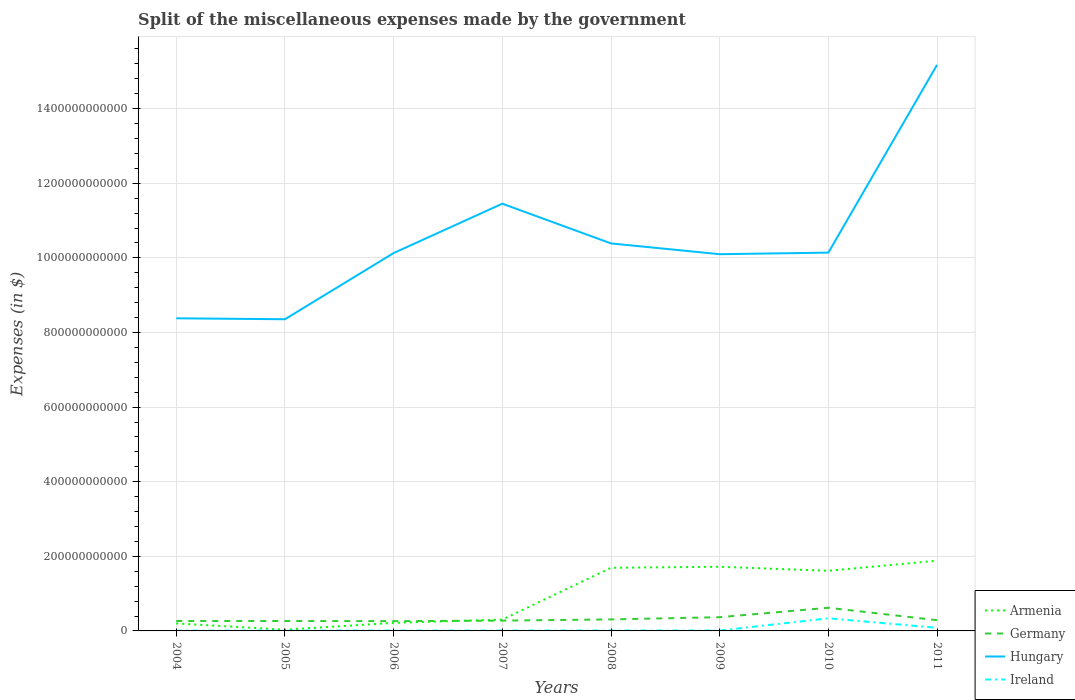How many different coloured lines are there?
Your answer should be compact. 4. Does the line corresponding to Ireland intersect with the line corresponding to Hungary?
Give a very brief answer. No. Across all years, what is the maximum miscellaneous expenses made by the government in Hungary?
Keep it short and to the point. 8.36e+11. What is the total miscellaneous expenses made by the government in Hungary in the graph?
Ensure brevity in your answer.  -5.08e+11. What is the difference between the highest and the second highest miscellaneous expenses made by the government in Armenia?
Provide a short and direct response. 1.85e+11. Is the miscellaneous expenses made by the government in Germany strictly greater than the miscellaneous expenses made by the government in Hungary over the years?
Your response must be concise. Yes. How many years are there in the graph?
Make the answer very short. 8. What is the difference between two consecutive major ticks on the Y-axis?
Offer a very short reply. 2.00e+11. Does the graph contain any zero values?
Make the answer very short. No. Where does the legend appear in the graph?
Your response must be concise. Bottom right. How are the legend labels stacked?
Provide a short and direct response. Vertical. What is the title of the graph?
Your response must be concise. Split of the miscellaneous expenses made by the government. Does "Middle East & North Africa (all income levels)" appear as one of the legend labels in the graph?
Offer a very short reply. No. What is the label or title of the X-axis?
Ensure brevity in your answer.  Years. What is the label or title of the Y-axis?
Offer a very short reply. Expenses (in $). What is the Expenses (in $) in Armenia in 2004?
Your response must be concise. 2.00e+1. What is the Expenses (in $) of Germany in 2004?
Offer a terse response. 2.66e+1. What is the Expenses (in $) of Hungary in 2004?
Keep it short and to the point. 8.38e+11. What is the Expenses (in $) in Ireland in 2004?
Give a very brief answer. 5.91e+08. What is the Expenses (in $) in Armenia in 2005?
Offer a terse response. 3.30e+09. What is the Expenses (in $) of Germany in 2005?
Provide a short and direct response. 2.66e+1. What is the Expenses (in $) of Hungary in 2005?
Provide a succinct answer. 8.36e+11. What is the Expenses (in $) in Ireland in 2005?
Make the answer very short. 7.97e+08. What is the Expenses (in $) of Armenia in 2006?
Provide a succinct answer. 2.16e+1. What is the Expenses (in $) in Germany in 2006?
Offer a terse response. 2.62e+1. What is the Expenses (in $) in Hungary in 2006?
Ensure brevity in your answer.  1.01e+12. What is the Expenses (in $) in Ireland in 2006?
Offer a very short reply. 9.16e+08. What is the Expenses (in $) of Armenia in 2007?
Ensure brevity in your answer.  3.04e+1. What is the Expenses (in $) of Germany in 2007?
Your answer should be compact. 2.76e+1. What is the Expenses (in $) of Hungary in 2007?
Your response must be concise. 1.15e+12. What is the Expenses (in $) in Ireland in 2007?
Keep it short and to the point. 9.75e+08. What is the Expenses (in $) of Armenia in 2008?
Provide a succinct answer. 1.69e+11. What is the Expenses (in $) in Germany in 2008?
Your answer should be compact. 3.09e+1. What is the Expenses (in $) of Hungary in 2008?
Provide a succinct answer. 1.04e+12. What is the Expenses (in $) in Ireland in 2008?
Offer a terse response. 1.01e+09. What is the Expenses (in $) of Armenia in 2009?
Offer a terse response. 1.72e+11. What is the Expenses (in $) in Germany in 2009?
Your answer should be very brief. 3.68e+1. What is the Expenses (in $) in Hungary in 2009?
Give a very brief answer. 1.01e+12. What is the Expenses (in $) in Ireland in 2009?
Offer a terse response. 9.94e+08. What is the Expenses (in $) in Armenia in 2010?
Offer a very short reply. 1.61e+11. What is the Expenses (in $) of Germany in 2010?
Provide a short and direct response. 6.21e+1. What is the Expenses (in $) of Hungary in 2010?
Ensure brevity in your answer.  1.01e+12. What is the Expenses (in $) in Ireland in 2010?
Provide a succinct answer. 3.38e+1. What is the Expenses (in $) of Armenia in 2011?
Keep it short and to the point. 1.88e+11. What is the Expenses (in $) in Germany in 2011?
Offer a terse response. 2.88e+1. What is the Expenses (in $) in Hungary in 2011?
Offer a very short reply. 1.52e+12. What is the Expenses (in $) of Ireland in 2011?
Offer a terse response. 8.39e+09. Across all years, what is the maximum Expenses (in $) of Armenia?
Ensure brevity in your answer.  1.88e+11. Across all years, what is the maximum Expenses (in $) of Germany?
Give a very brief answer. 6.21e+1. Across all years, what is the maximum Expenses (in $) of Hungary?
Provide a short and direct response. 1.52e+12. Across all years, what is the maximum Expenses (in $) of Ireland?
Keep it short and to the point. 3.38e+1. Across all years, what is the minimum Expenses (in $) in Armenia?
Provide a succinct answer. 3.30e+09. Across all years, what is the minimum Expenses (in $) in Germany?
Provide a short and direct response. 2.62e+1. Across all years, what is the minimum Expenses (in $) of Hungary?
Provide a short and direct response. 8.36e+11. Across all years, what is the minimum Expenses (in $) in Ireland?
Provide a short and direct response. 5.91e+08. What is the total Expenses (in $) in Armenia in the graph?
Your answer should be compact. 7.66e+11. What is the total Expenses (in $) in Germany in the graph?
Provide a short and direct response. 2.66e+11. What is the total Expenses (in $) in Hungary in the graph?
Your answer should be very brief. 8.41e+12. What is the total Expenses (in $) of Ireland in the graph?
Give a very brief answer. 4.74e+1. What is the difference between the Expenses (in $) in Armenia in 2004 and that in 2005?
Keep it short and to the point. 1.67e+1. What is the difference between the Expenses (in $) of Hungary in 2004 and that in 2005?
Offer a terse response. 2.54e+09. What is the difference between the Expenses (in $) of Ireland in 2004 and that in 2005?
Make the answer very short. -2.06e+08. What is the difference between the Expenses (in $) of Armenia in 2004 and that in 2006?
Your answer should be compact. -1.57e+09. What is the difference between the Expenses (in $) in Germany in 2004 and that in 2006?
Your answer should be very brief. 3.70e+08. What is the difference between the Expenses (in $) in Hungary in 2004 and that in 2006?
Your answer should be very brief. -1.75e+11. What is the difference between the Expenses (in $) of Ireland in 2004 and that in 2006?
Give a very brief answer. -3.25e+08. What is the difference between the Expenses (in $) of Armenia in 2004 and that in 2007?
Offer a very short reply. -1.04e+1. What is the difference between the Expenses (in $) of Germany in 2004 and that in 2007?
Your answer should be compact. -1.01e+09. What is the difference between the Expenses (in $) in Hungary in 2004 and that in 2007?
Make the answer very short. -3.07e+11. What is the difference between the Expenses (in $) of Ireland in 2004 and that in 2007?
Make the answer very short. -3.84e+08. What is the difference between the Expenses (in $) in Armenia in 2004 and that in 2008?
Your answer should be compact. -1.49e+11. What is the difference between the Expenses (in $) of Germany in 2004 and that in 2008?
Make the answer very short. -4.29e+09. What is the difference between the Expenses (in $) of Hungary in 2004 and that in 2008?
Give a very brief answer. -2.01e+11. What is the difference between the Expenses (in $) in Ireland in 2004 and that in 2008?
Your answer should be compact. -4.15e+08. What is the difference between the Expenses (in $) in Armenia in 2004 and that in 2009?
Provide a short and direct response. -1.52e+11. What is the difference between the Expenses (in $) of Germany in 2004 and that in 2009?
Your answer should be very brief. -1.02e+1. What is the difference between the Expenses (in $) of Hungary in 2004 and that in 2009?
Your answer should be very brief. -1.72e+11. What is the difference between the Expenses (in $) of Ireland in 2004 and that in 2009?
Keep it short and to the point. -4.03e+08. What is the difference between the Expenses (in $) of Armenia in 2004 and that in 2010?
Keep it short and to the point. -1.41e+11. What is the difference between the Expenses (in $) in Germany in 2004 and that in 2010?
Your response must be concise. -3.55e+1. What is the difference between the Expenses (in $) in Hungary in 2004 and that in 2010?
Your response must be concise. -1.76e+11. What is the difference between the Expenses (in $) of Ireland in 2004 and that in 2010?
Make the answer very short. -3.32e+1. What is the difference between the Expenses (in $) of Armenia in 2004 and that in 2011?
Ensure brevity in your answer.  -1.68e+11. What is the difference between the Expenses (in $) in Germany in 2004 and that in 2011?
Provide a short and direct response. -2.20e+09. What is the difference between the Expenses (in $) in Hungary in 2004 and that in 2011?
Your answer should be very brief. -6.79e+11. What is the difference between the Expenses (in $) of Ireland in 2004 and that in 2011?
Give a very brief answer. -7.80e+09. What is the difference between the Expenses (in $) in Armenia in 2005 and that in 2006?
Offer a terse response. -1.83e+1. What is the difference between the Expenses (in $) in Germany in 2005 and that in 2006?
Provide a succinct answer. 3.70e+08. What is the difference between the Expenses (in $) in Hungary in 2005 and that in 2006?
Your response must be concise. -1.77e+11. What is the difference between the Expenses (in $) in Ireland in 2005 and that in 2006?
Your response must be concise. -1.19e+08. What is the difference between the Expenses (in $) of Armenia in 2005 and that in 2007?
Your answer should be compact. -2.71e+1. What is the difference between the Expenses (in $) in Germany in 2005 and that in 2007?
Your answer should be compact. -1.01e+09. What is the difference between the Expenses (in $) of Hungary in 2005 and that in 2007?
Offer a very short reply. -3.10e+11. What is the difference between the Expenses (in $) in Ireland in 2005 and that in 2007?
Ensure brevity in your answer.  -1.78e+08. What is the difference between the Expenses (in $) in Armenia in 2005 and that in 2008?
Give a very brief answer. -1.66e+11. What is the difference between the Expenses (in $) of Germany in 2005 and that in 2008?
Your answer should be very brief. -4.29e+09. What is the difference between the Expenses (in $) in Hungary in 2005 and that in 2008?
Your answer should be very brief. -2.03e+11. What is the difference between the Expenses (in $) of Ireland in 2005 and that in 2008?
Give a very brief answer. -2.09e+08. What is the difference between the Expenses (in $) in Armenia in 2005 and that in 2009?
Give a very brief answer. -1.69e+11. What is the difference between the Expenses (in $) in Germany in 2005 and that in 2009?
Your answer should be compact. -1.02e+1. What is the difference between the Expenses (in $) in Hungary in 2005 and that in 2009?
Offer a terse response. -1.74e+11. What is the difference between the Expenses (in $) in Ireland in 2005 and that in 2009?
Keep it short and to the point. -1.97e+08. What is the difference between the Expenses (in $) in Armenia in 2005 and that in 2010?
Your response must be concise. -1.58e+11. What is the difference between the Expenses (in $) of Germany in 2005 and that in 2010?
Your answer should be very brief. -3.55e+1. What is the difference between the Expenses (in $) in Hungary in 2005 and that in 2010?
Offer a very short reply. -1.79e+11. What is the difference between the Expenses (in $) of Ireland in 2005 and that in 2010?
Provide a short and direct response. -3.30e+1. What is the difference between the Expenses (in $) in Armenia in 2005 and that in 2011?
Your answer should be very brief. -1.85e+11. What is the difference between the Expenses (in $) in Germany in 2005 and that in 2011?
Your answer should be very brief. -2.20e+09. What is the difference between the Expenses (in $) in Hungary in 2005 and that in 2011?
Provide a short and direct response. -6.82e+11. What is the difference between the Expenses (in $) in Ireland in 2005 and that in 2011?
Your answer should be very brief. -7.59e+09. What is the difference between the Expenses (in $) in Armenia in 2006 and that in 2007?
Your response must be concise. -8.79e+09. What is the difference between the Expenses (in $) of Germany in 2006 and that in 2007?
Provide a succinct answer. -1.38e+09. What is the difference between the Expenses (in $) in Hungary in 2006 and that in 2007?
Make the answer very short. -1.32e+11. What is the difference between the Expenses (in $) in Ireland in 2006 and that in 2007?
Offer a terse response. -5.92e+07. What is the difference between the Expenses (in $) in Armenia in 2006 and that in 2008?
Provide a short and direct response. -1.48e+11. What is the difference between the Expenses (in $) of Germany in 2006 and that in 2008?
Your answer should be very brief. -4.66e+09. What is the difference between the Expenses (in $) in Hungary in 2006 and that in 2008?
Your response must be concise. -2.59e+1. What is the difference between the Expenses (in $) in Ireland in 2006 and that in 2008?
Offer a very short reply. -9.02e+07. What is the difference between the Expenses (in $) in Armenia in 2006 and that in 2009?
Offer a terse response. -1.50e+11. What is the difference between the Expenses (in $) in Germany in 2006 and that in 2009?
Provide a succinct answer. -1.06e+1. What is the difference between the Expenses (in $) in Hungary in 2006 and that in 2009?
Make the answer very short. 3.08e+09. What is the difference between the Expenses (in $) in Ireland in 2006 and that in 2009?
Provide a succinct answer. -7.75e+07. What is the difference between the Expenses (in $) in Armenia in 2006 and that in 2010?
Your response must be concise. -1.40e+11. What is the difference between the Expenses (in $) in Germany in 2006 and that in 2010?
Keep it short and to the point. -3.59e+1. What is the difference between the Expenses (in $) of Hungary in 2006 and that in 2010?
Your answer should be very brief. -1.16e+09. What is the difference between the Expenses (in $) of Ireland in 2006 and that in 2010?
Your answer should be compact. -3.29e+1. What is the difference between the Expenses (in $) of Armenia in 2006 and that in 2011?
Provide a short and direct response. -1.67e+11. What is the difference between the Expenses (in $) in Germany in 2006 and that in 2011?
Offer a very short reply. -2.57e+09. What is the difference between the Expenses (in $) in Hungary in 2006 and that in 2011?
Offer a very short reply. -5.05e+11. What is the difference between the Expenses (in $) of Ireland in 2006 and that in 2011?
Your answer should be very brief. -7.47e+09. What is the difference between the Expenses (in $) in Armenia in 2007 and that in 2008?
Keep it short and to the point. -1.39e+11. What is the difference between the Expenses (in $) in Germany in 2007 and that in 2008?
Provide a succinct answer. -3.28e+09. What is the difference between the Expenses (in $) in Hungary in 2007 and that in 2008?
Ensure brevity in your answer.  1.06e+11. What is the difference between the Expenses (in $) of Ireland in 2007 and that in 2008?
Offer a terse response. -3.10e+07. What is the difference between the Expenses (in $) of Armenia in 2007 and that in 2009?
Your answer should be very brief. -1.42e+11. What is the difference between the Expenses (in $) in Germany in 2007 and that in 2009?
Make the answer very short. -9.24e+09. What is the difference between the Expenses (in $) in Hungary in 2007 and that in 2009?
Make the answer very short. 1.35e+11. What is the difference between the Expenses (in $) of Ireland in 2007 and that in 2009?
Offer a terse response. -1.83e+07. What is the difference between the Expenses (in $) of Armenia in 2007 and that in 2010?
Keep it short and to the point. -1.31e+11. What is the difference between the Expenses (in $) in Germany in 2007 and that in 2010?
Provide a short and direct response. -3.45e+1. What is the difference between the Expenses (in $) of Hungary in 2007 and that in 2010?
Your answer should be compact. 1.31e+11. What is the difference between the Expenses (in $) in Ireland in 2007 and that in 2010?
Your response must be concise. -3.28e+1. What is the difference between the Expenses (in $) in Armenia in 2007 and that in 2011?
Your response must be concise. -1.58e+11. What is the difference between the Expenses (in $) in Germany in 2007 and that in 2011?
Give a very brief answer. -1.19e+09. What is the difference between the Expenses (in $) in Hungary in 2007 and that in 2011?
Ensure brevity in your answer.  -3.72e+11. What is the difference between the Expenses (in $) of Ireland in 2007 and that in 2011?
Keep it short and to the point. -7.41e+09. What is the difference between the Expenses (in $) of Armenia in 2008 and that in 2009?
Keep it short and to the point. -2.76e+09. What is the difference between the Expenses (in $) in Germany in 2008 and that in 2009?
Your answer should be very brief. -5.96e+09. What is the difference between the Expenses (in $) of Hungary in 2008 and that in 2009?
Give a very brief answer. 2.90e+1. What is the difference between the Expenses (in $) of Ireland in 2008 and that in 2009?
Provide a succinct answer. 1.27e+07. What is the difference between the Expenses (in $) in Armenia in 2008 and that in 2010?
Give a very brief answer. 8.07e+09. What is the difference between the Expenses (in $) in Germany in 2008 and that in 2010?
Provide a succinct answer. -3.12e+1. What is the difference between the Expenses (in $) in Hungary in 2008 and that in 2010?
Offer a terse response. 2.47e+1. What is the difference between the Expenses (in $) in Ireland in 2008 and that in 2010?
Your answer should be compact. -3.28e+1. What is the difference between the Expenses (in $) of Armenia in 2008 and that in 2011?
Make the answer very short. -1.91e+1. What is the difference between the Expenses (in $) of Germany in 2008 and that in 2011?
Provide a short and direct response. 2.09e+09. What is the difference between the Expenses (in $) in Hungary in 2008 and that in 2011?
Provide a succinct answer. -4.79e+11. What is the difference between the Expenses (in $) of Ireland in 2008 and that in 2011?
Make the answer very short. -7.38e+09. What is the difference between the Expenses (in $) of Armenia in 2009 and that in 2010?
Provide a succinct answer. 1.08e+1. What is the difference between the Expenses (in $) in Germany in 2009 and that in 2010?
Offer a terse response. -2.52e+1. What is the difference between the Expenses (in $) in Hungary in 2009 and that in 2010?
Your answer should be very brief. -4.23e+09. What is the difference between the Expenses (in $) in Ireland in 2009 and that in 2010?
Offer a very short reply. -3.28e+1. What is the difference between the Expenses (in $) in Armenia in 2009 and that in 2011?
Your response must be concise. -1.63e+1. What is the difference between the Expenses (in $) in Germany in 2009 and that in 2011?
Ensure brevity in your answer.  8.05e+09. What is the difference between the Expenses (in $) in Hungary in 2009 and that in 2011?
Your response must be concise. -5.08e+11. What is the difference between the Expenses (in $) of Ireland in 2009 and that in 2011?
Offer a very short reply. -7.39e+09. What is the difference between the Expenses (in $) of Armenia in 2010 and that in 2011?
Provide a short and direct response. -2.71e+1. What is the difference between the Expenses (in $) of Germany in 2010 and that in 2011?
Offer a terse response. 3.33e+1. What is the difference between the Expenses (in $) in Hungary in 2010 and that in 2011?
Your answer should be very brief. -5.03e+11. What is the difference between the Expenses (in $) in Ireland in 2010 and that in 2011?
Ensure brevity in your answer.  2.54e+1. What is the difference between the Expenses (in $) of Armenia in 2004 and the Expenses (in $) of Germany in 2005?
Offer a terse response. -6.55e+09. What is the difference between the Expenses (in $) of Armenia in 2004 and the Expenses (in $) of Hungary in 2005?
Keep it short and to the point. -8.15e+11. What is the difference between the Expenses (in $) in Armenia in 2004 and the Expenses (in $) in Ireland in 2005?
Keep it short and to the point. 1.92e+1. What is the difference between the Expenses (in $) in Germany in 2004 and the Expenses (in $) in Hungary in 2005?
Make the answer very short. -8.09e+11. What is the difference between the Expenses (in $) of Germany in 2004 and the Expenses (in $) of Ireland in 2005?
Your answer should be compact. 2.58e+1. What is the difference between the Expenses (in $) in Hungary in 2004 and the Expenses (in $) in Ireland in 2005?
Provide a succinct answer. 8.37e+11. What is the difference between the Expenses (in $) of Armenia in 2004 and the Expenses (in $) of Germany in 2006?
Provide a succinct answer. -6.18e+09. What is the difference between the Expenses (in $) in Armenia in 2004 and the Expenses (in $) in Hungary in 2006?
Offer a very short reply. -9.93e+11. What is the difference between the Expenses (in $) in Armenia in 2004 and the Expenses (in $) in Ireland in 2006?
Your answer should be compact. 1.91e+1. What is the difference between the Expenses (in $) in Germany in 2004 and the Expenses (in $) in Hungary in 2006?
Provide a short and direct response. -9.86e+11. What is the difference between the Expenses (in $) in Germany in 2004 and the Expenses (in $) in Ireland in 2006?
Offer a terse response. 2.57e+1. What is the difference between the Expenses (in $) of Hungary in 2004 and the Expenses (in $) of Ireland in 2006?
Make the answer very short. 8.37e+11. What is the difference between the Expenses (in $) of Armenia in 2004 and the Expenses (in $) of Germany in 2007?
Give a very brief answer. -7.56e+09. What is the difference between the Expenses (in $) of Armenia in 2004 and the Expenses (in $) of Hungary in 2007?
Offer a very short reply. -1.13e+12. What is the difference between the Expenses (in $) in Armenia in 2004 and the Expenses (in $) in Ireland in 2007?
Your answer should be compact. 1.91e+1. What is the difference between the Expenses (in $) of Germany in 2004 and the Expenses (in $) of Hungary in 2007?
Ensure brevity in your answer.  -1.12e+12. What is the difference between the Expenses (in $) in Germany in 2004 and the Expenses (in $) in Ireland in 2007?
Offer a terse response. 2.56e+1. What is the difference between the Expenses (in $) of Hungary in 2004 and the Expenses (in $) of Ireland in 2007?
Offer a terse response. 8.37e+11. What is the difference between the Expenses (in $) in Armenia in 2004 and the Expenses (in $) in Germany in 2008?
Your answer should be very brief. -1.08e+1. What is the difference between the Expenses (in $) in Armenia in 2004 and the Expenses (in $) in Hungary in 2008?
Offer a terse response. -1.02e+12. What is the difference between the Expenses (in $) of Armenia in 2004 and the Expenses (in $) of Ireland in 2008?
Keep it short and to the point. 1.90e+1. What is the difference between the Expenses (in $) in Germany in 2004 and the Expenses (in $) in Hungary in 2008?
Your answer should be compact. -1.01e+12. What is the difference between the Expenses (in $) of Germany in 2004 and the Expenses (in $) of Ireland in 2008?
Make the answer very short. 2.56e+1. What is the difference between the Expenses (in $) in Hungary in 2004 and the Expenses (in $) in Ireland in 2008?
Provide a short and direct response. 8.37e+11. What is the difference between the Expenses (in $) of Armenia in 2004 and the Expenses (in $) of Germany in 2009?
Keep it short and to the point. -1.68e+1. What is the difference between the Expenses (in $) of Armenia in 2004 and the Expenses (in $) of Hungary in 2009?
Give a very brief answer. -9.90e+11. What is the difference between the Expenses (in $) in Armenia in 2004 and the Expenses (in $) in Ireland in 2009?
Offer a terse response. 1.90e+1. What is the difference between the Expenses (in $) of Germany in 2004 and the Expenses (in $) of Hungary in 2009?
Offer a terse response. -9.83e+11. What is the difference between the Expenses (in $) of Germany in 2004 and the Expenses (in $) of Ireland in 2009?
Your response must be concise. 2.56e+1. What is the difference between the Expenses (in $) of Hungary in 2004 and the Expenses (in $) of Ireland in 2009?
Offer a very short reply. 8.37e+11. What is the difference between the Expenses (in $) in Armenia in 2004 and the Expenses (in $) in Germany in 2010?
Your answer should be compact. -4.20e+1. What is the difference between the Expenses (in $) of Armenia in 2004 and the Expenses (in $) of Hungary in 2010?
Keep it short and to the point. -9.94e+11. What is the difference between the Expenses (in $) in Armenia in 2004 and the Expenses (in $) in Ireland in 2010?
Keep it short and to the point. -1.37e+1. What is the difference between the Expenses (in $) in Germany in 2004 and the Expenses (in $) in Hungary in 2010?
Give a very brief answer. -9.88e+11. What is the difference between the Expenses (in $) of Germany in 2004 and the Expenses (in $) of Ireland in 2010?
Your answer should be very brief. -7.18e+09. What is the difference between the Expenses (in $) of Hungary in 2004 and the Expenses (in $) of Ireland in 2010?
Offer a terse response. 8.04e+11. What is the difference between the Expenses (in $) of Armenia in 2004 and the Expenses (in $) of Germany in 2011?
Give a very brief answer. -8.75e+09. What is the difference between the Expenses (in $) of Armenia in 2004 and the Expenses (in $) of Hungary in 2011?
Provide a short and direct response. -1.50e+12. What is the difference between the Expenses (in $) in Armenia in 2004 and the Expenses (in $) in Ireland in 2011?
Keep it short and to the point. 1.17e+1. What is the difference between the Expenses (in $) in Germany in 2004 and the Expenses (in $) in Hungary in 2011?
Offer a terse response. -1.49e+12. What is the difference between the Expenses (in $) in Germany in 2004 and the Expenses (in $) in Ireland in 2011?
Make the answer very short. 1.82e+1. What is the difference between the Expenses (in $) in Hungary in 2004 and the Expenses (in $) in Ireland in 2011?
Your answer should be very brief. 8.30e+11. What is the difference between the Expenses (in $) of Armenia in 2005 and the Expenses (in $) of Germany in 2006?
Keep it short and to the point. -2.29e+1. What is the difference between the Expenses (in $) of Armenia in 2005 and the Expenses (in $) of Hungary in 2006?
Provide a succinct answer. -1.01e+12. What is the difference between the Expenses (in $) of Armenia in 2005 and the Expenses (in $) of Ireland in 2006?
Offer a terse response. 2.39e+09. What is the difference between the Expenses (in $) of Germany in 2005 and the Expenses (in $) of Hungary in 2006?
Your answer should be compact. -9.86e+11. What is the difference between the Expenses (in $) in Germany in 2005 and the Expenses (in $) in Ireland in 2006?
Provide a short and direct response. 2.57e+1. What is the difference between the Expenses (in $) in Hungary in 2005 and the Expenses (in $) in Ireland in 2006?
Give a very brief answer. 8.35e+11. What is the difference between the Expenses (in $) in Armenia in 2005 and the Expenses (in $) in Germany in 2007?
Your answer should be very brief. -2.43e+1. What is the difference between the Expenses (in $) of Armenia in 2005 and the Expenses (in $) of Hungary in 2007?
Provide a short and direct response. -1.14e+12. What is the difference between the Expenses (in $) of Armenia in 2005 and the Expenses (in $) of Ireland in 2007?
Provide a short and direct response. 2.33e+09. What is the difference between the Expenses (in $) of Germany in 2005 and the Expenses (in $) of Hungary in 2007?
Your answer should be very brief. -1.12e+12. What is the difference between the Expenses (in $) in Germany in 2005 and the Expenses (in $) in Ireland in 2007?
Provide a succinct answer. 2.56e+1. What is the difference between the Expenses (in $) of Hungary in 2005 and the Expenses (in $) of Ireland in 2007?
Offer a terse response. 8.35e+11. What is the difference between the Expenses (in $) of Armenia in 2005 and the Expenses (in $) of Germany in 2008?
Ensure brevity in your answer.  -2.76e+1. What is the difference between the Expenses (in $) of Armenia in 2005 and the Expenses (in $) of Hungary in 2008?
Make the answer very short. -1.04e+12. What is the difference between the Expenses (in $) in Armenia in 2005 and the Expenses (in $) in Ireland in 2008?
Give a very brief answer. 2.30e+09. What is the difference between the Expenses (in $) of Germany in 2005 and the Expenses (in $) of Hungary in 2008?
Give a very brief answer. -1.01e+12. What is the difference between the Expenses (in $) in Germany in 2005 and the Expenses (in $) in Ireland in 2008?
Give a very brief answer. 2.56e+1. What is the difference between the Expenses (in $) of Hungary in 2005 and the Expenses (in $) of Ireland in 2008?
Your answer should be very brief. 8.35e+11. What is the difference between the Expenses (in $) of Armenia in 2005 and the Expenses (in $) of Germany in 2009?
Your answer should be very brief. -3.35e+1. What is the difference between the Expenses (in $) of Armenia in 2005 and the Expenses (in $) of Hungary in 2009?
Ensure brevity in your answer.  -1.01e+12. What is the difference between the Expenses (in $) in Armenia in 2005 and the Expenses (in $) in Ireland in 2009?
Offer a very short reply. 2.31e+09. What is the difference between the Expenses (in $) in Germany in 2005 and the Expenses (in $) in Hungary in 2009?
Make the answer very short. -9.83e+11. What is the difference between the Expenses (in $) of Germany in 2005 and the Expenses (in $) of Ireland in 2009?
Your answer should be compact. 2.56e+1. What is the difference between the Expenses (in $) of Hungary in 2005 and the Expenses (in $) of Ireland in 2009?
Offer a terse response. 8.35e+11. What is the difference between the Expenses (in $) in Armenia in 2005 and the Expenses (in $) in Germany in 2010?
Provide a succinct answer. -5.88e+1. What is the difference between the Expenses (in $) of Armenia in 2005 and the Expenses (in $) of Hungary in 2010?
Make the answer very short. -1.01e+12. What is the difference between the Expenses (in $) of Armenia in 2005 and the Expenses (in $) of Ireland in 2010?
Your answer should be compact. -3.05e+1. What is the difference between the Expenses (in $) of Germany in 2005 and the Expenses (in $) of Hungary in 2010?
Your response must be concise. -9.88e+11. What is the difference between the Expenses (in $) of Germany in 2005 and the Expenses (in $) of Ireland in 2010?
Keep it short and to the point. -7.18e+09. What is the difference between the Expenses (in $) in Hungary in 2005 and the Expenses (in $) in Ireland in 2010?
Provide a succinct answer. 8.02e+11. What is the difference between the Expenses (in $) in Armenia in 2005 and the Expenses (in $) in Germany in 2011?
Provide a short and direct response. -2.55e+1. What is the difference between the Expenses (in $) of Armenia in 2005 and the Expenses (in $) of Hungary in 2011?
Make the answer very short. -1.51e+12. What is the difference between the Expenses (in $) in Armenia in 2005 and the Expenses (in $) in Ireland in 2011?
Keep it short and to the point. -5.08e+09. What is the difference between the Expenses (in $) in Germany in 2005 and the Expenses (in $) in Hungary in 2011?
Offer a very short reply. -1.49e+12. What is the difference between the Expenses (in $) of Germany in 2005 and the Expenses (in $) of Ireland in 2011?
Give a very brief answer. 1.82e+1. What is the difference between the Expenses (in $) of Hungary in 2005 and the Expenses (in $) of Ireland in 2011?
Your response must be concise. 8.27e+11. What is the difference between the Expenses (in $) of Armenia in 2006 and the Expenses (in $) of Germany in 2007?
Offer a terse response. -5.98e+09. What is the difference between the Expenses (in $) of Armenia in 2006 and the Expenses (in $) of Hungary in 2007?
Provide a succinct answer. -1.12e+12. What is the difference between the Expenses (in $) in Armenia in 2006 and the Expenses (in $) in Ireland in 2007?
Provide a short and direct response. 2.06e+1. What is the difference between the Expenses (in $) of Germany in 2006 and the Expenses (in $) of Hungary in 2007?
Make the answer very short. -1.12e+12. What is the difference between the Expenses (in $) in Germany in 2006 and the Expenses (in $) in Ireland in 2007?
Ensure brevity in your answer.  2.52e+1. What is the difference between the Expenses (in $) of Hungary in 2006 and the Expenses (in $) of Ireland in 2007?
Make the answer very short. 1.01e+12. What is the difference between the Expenses (in $) of Armenia in 2006 and the Expenses (in $) of Germany in 2008?
Your answer should be very brief. -9.26e+09. What is the difference between the Expenses (in $) of Armenia in 2006 and the Expenses (in $) of Hungary in 2008?
Keep it short and to the point. -1.02e+12. What is the difference between the Expenses (in $) of Armenia in 2006 and the Expenses (in $) of Ireland in 2008?
Provide a short and direct response. 2.06e+1. What is the difference between the Expenses (in $) of Germany in 2006 and the Expenses (in $) of Hungary in 2008?
Make the answer very short. -1.01e+12. What is the difference between the Expenses (in $) in Germany in 2006 and the Expenses (in $) in Ireland in 2008?
Offer a terse response. 2.52e+1. What is the difference between the Expenses (in $) in Hungary in 2006 and the Expenses (in $) in Ireland in 2008?
Offer a terse response. 1.01e+12. What is the difference between the Expenses (in $) of Armenia in 2006 and the Expenses (in $) of Germany in 2009?
Your answer should be very brief. -1.52e+1. What is the difference between the Expenses (in $) in Armenia in 2006 and the Expenses (in $) in Hungary in 2009?
Offer a terse response. -9.88e+11. What is the difference between the Expenses (in $) of Armenia in 2006 and the Expenses (in $) of Ireland in 2009?
Your answer should be very brief. 2.06e+1. What is the difference between the Expenses (in $) of Germany in 2006 and the Expenses (in $) of Hungary in 2009?
Keep it short and to the point. -9.84e+11. What is the difference between the Expenses (in $) of Germany in 2006 and the Expenses (in $) of Ireland in 2009?
Your answer should be very brief. 2.52e+1. What is the difference between the Expenses (in $) in Hungary in 2006 and the Expenses (in $) in Ireland in 2009?
Provide a succinct answer. 1.01e+12. What is the difference between the Expenses (in $) in Armenia in 2006 and the Expenses (in $) in Germany in 2010?
Provide a short and direct response. -4.05e+1. What is the difference between the Expenses (in $) of Armenia in 2006 and the Expenses (in $) of Hungary in 2010?
Provide a succinct answer. -9.92e+11. What is the difference between the Expenses (in $) of Armenia in 2006 and the Expenses (in $) of Ireland in 2010?
Make the answer very short. -1.22e+1. What is the difference between the Expenses (in $) in Germany in 2006 and the Expenses (in $) in Hungary in 2010?
Offer a very short reply. -9.88e+11. What is the difference between the Expenses (in $) in Germany in 2006 and the Expenses (in $) in Ireland in 2010?
Provide a succinct answer. -7.55e+09. What is the difference between the Expenses (in $) in Hungary in 2006 and the Expenses (in $) in Ireland in 2010?
Provide a succinct answer. 9.79e+11. What is the difference between the Expenses (in $) in Armenia in 2006 and the Expenses (in $) in Germany in 2011?
Give a very brief answer. -7.17e+09. What is the difference between the Expenses (in $) of Armenia in 2006 and the Expenses (in $) of Hungary in 2011?
Make the answer very short. -1.50e+12. What is the difference between the Expenses (in $) of Armenia in 2006 and the Expenses (in $) of Ireland in 2011?
Your answer should be very brief. 1.32e+1. What is the difference between the Expenses (in $) in Germany in 2006 and the Expenses (in $) in Hungary in 2011?
Your answer should be compact. -1.49e+12. What is the difference between the Expenses (in $) of Germany in 2006 and the Expenses (in $) of Ireland in 2011?
Make the answer very short. 1.78e+1. What is the difference between the Expenses (in $) in Hungary in 2006 and the Expenses (in $) in Ireland in 2011?
Offer a terse response. 1.00e+12. What is the difference between the Expenses (in $) of Armenia in 2007 and the Expenses (in $) of Germany in 2008?
Offer a very short reply. -4.75e+08. What is the difference between the Expenses (in $) of Armenia in 2007 and the Expenses (in $) of Hungary in 2008?
Offer a very short reply. -1.01e+12. What is the difference between the Expenses (in $) in Armenia in 2007 and the Expenses (in $) in Ireland in 2008?
Ensure brevity in your answer.  2.94e+1. What is the difference between the Expenses (in $) in Germany in 2007 and the Expenses (in $) in Hungary in 2008?
Provide a succinct answer. -1.01e+12. What is the difference between the Expenses (in $) in Germany in 2007 and the Expenses (in $) in Ireland in 2008?
Give a very brief answer. 2.66e+1. What is the difference between the Expenses (in $) in Hungary in 2007 and the Expenses (in $) in Ireland in 2008?
Provide a short and direct response. 1.14e+12. What is the difference between the Expenses (in $) in Armenia in 2007 and the Expenses (in $) in Germany in 2009?
Offer a terse response. -6.44e+09. What is the difference between the Expenses (in $) of Armenia in 2007 and the Expenses (in $) of Hungary in 2009?
Your answer should be compact. -9.79e+11. What is the difference between the Expenses (in $) of Armenia in 2007 and the Expenses (in $) of Ireland in 2009?
Offer a terse response. 2.94e+1. What is the difference between the Expenses (in $) in Germany in 2007 and the Expenses (in $) in Hungary in 2009?
Give a very brief answer. -9.82e+11. What is the difference between the Expenses (in $) in Germany in 2007 and the Expenses (in $) in Ireland in 2009?
Your response must be concise. 2.66e+1. What is the difference between the Expenses (in $) in Hungary in 2007 and the Expenses (in $) in Ireland in 2009?
Provide a succinct answer. 1.14e+12. What is the difference between the Expenses (in $) of Armenia in 2007 and the Expenses (in $) of Germany in 2010?
Ensure brevity in your answer.  -3.17e+1. What is the difference between the Expenses (in $) in Armenia in 2007 and the Expenses (in $) in Hungary in 2010?
Ensure brevity in your answer.  -9.84e+11. What is the difference between the Expenses (in $) of Armenia in 2007 and the Expenses (in $) of Ireland in 2010?
Your answer should be compact. -3.37e+09. What is the difference between the Expenses (in $) of Germany in 2007 and the Expenses (in $) of Hungary in 2010?
Provide a short and direct response. -9.87e+11. What is the difference between the Expenses (in $) of Germany in 2007 and the Expenses (in $) of Ireland in 2010?
Your answer should be very brief. -6.17e+09. What is the difference between the Expenses (in $) in Hungary in 2007 and the Expenses (in $) in Ireland in 2010?
Offer a very short reply. 1.11e+12. What is the difference between the Expenses (in $) of Armenia in 2007 and the Expenses (in $) of Germany in 2011?
Offer a very short reply. 1.61e+09. What is the difference between the Expenses (in $) of Armenia in 2007 and the Expenses (in $) of Hungary in 2011?
Make the answer very short. -1.49e+12. What is the difference between the Expenses (in $) of Armenia in 2007 and the Expenses (in $) of Ireland in 2011?
Ensure brevity in your answer.  2.20e+1. What is the difference between the Expenses (in $) of Germany in 2007 and the Expenses (in $) of Hungary in 2011?
Keep it short and to the point. -1.49e+12. What is the difference between the Expenses (in $) in Germany in 2007 and the Expenses (in $) in Ireland in 2011?
Your answer should be compact. 1.92e+1. What is the difference between the Expenses (in $) in Hungary in 2007 and the Expenses (in $) in Ireland in 2011?
Offer a very short reply. 1.14e+12. What is the difference between the Expenses (in $) in Armenia in 2008 and the Expenses (in $) in Germany in 2009?
Your answer should be compact. 1.32e+11. What is the difference between the Expenses (in $) of Armenia in 2008 and the Expenses (in $) of Hungary in 2009?
Ensure brevity in your answer.  -8.41e+11. What is the difference between the Expenses (in $) of Armenia in 2008 and the Expenses (in $) of Ireland in 2009?
Provide a short and direct response. 1.68e+11. What is the difference between the Expenses (in $) in Germany in 2008 and the Expenses (in $) in Hungary in 2009?
Offer a terse response. -9.79e+11. What is the difference between the Expenses (in $) of Germany in 2008 and the Expenses (in $) of Ireland in 2009?
Offer a terse response. 2.99e+1. What is the difference between the Expenses (in $) of Hungary in 2008 and the Expenses (in $) of Ireland in 2009?
Offer a very short reply. 1.04e+12. What is the difference between the Expenses (in $) of Armenia in 2008 and the Expenses (in $) of Germany in 2010?
Offer a very short reply. 1.07e+11. What is the difference between the Expenses (in $) in Armenia in 2008 and the Expenses (in $) in Hungary in 2010?
Keep it short and to the point. -8.45e+11. What is the difference between the Expenses (in $) in Armenia in 2008 and the Expenses (in $) in Ireland in 2010?
Your response must be concise. 1.35e+11. What is the difference between the Expenses (in $) of Germany in 2008 and the Expenses (in $) of Hungary in 2010?
Give a very brief answer. -9.83e+11. What is the difference between the Expenses (in $) of Germany in 2008 and the Expenses (in $) of Ireland in 2010?
Your response must be concise. -2.89e+09. What is the difference between the Expenses (in $) of Hungary in 2008 and the Expenses (in $) of Ireland in 2010?
Ensure brevity in your answer.  1.01e+12. What is the difference between the Expenses (in $) of Armenia in 2008 and the Expenses (in $) of Germany in 2011?
Your answer should be compact. 1.40e+11. What is the difference between the Expenses (in $) of Armenia in 2008 and the Expenses (in $) of Hungary in 2011?
Make the answer very short. -1.35e+12. What is the difference between the Expenses (in $) of Armenia in 2008 and the Expenses (in $) of Ireland in 2011?
Your answer should be compact. 1.61e+11. What is the difference between the Expenses (in $) in Germany in 2008 and the Expenses (in $) in Hungary in 2011?
Make the answer very short. -1.49e+12. What is the difference between the Expenses (in $) of Germany in 2008 and the Expenses (in $) of Ireland in 2011?
Ensure brevity in your answer.  2.25e+1. What is the difference between the Expenses (in $) in Hungary in 2008 and the Expenses (in $) in Ireland in 2011?
Provide a short and direct response. 1.03e+12. What is the difference between the Expenses (in $) in Armenia in 2009 and the Expenses (in $) in Germany in 2010?
Provide a short and direct response. 1.10e+11. What is the difference between the Expenses (in $) in Armenia in 2009 and the Expenses (in $) in Hungary in 2010?
Keep it short and to the point. -8.42e+11. What is the difference between the Expenses (in $) of Armenia in 2009 and the Expenses (in $) of Ireland in 2010?
Ensure brevity in your answer.  1.38e+11. What is the difference between the Expenses (in $) of Germany in 2009 and the Expenses (in $) of Hungary in 2010?
Your answer should be compact. -9.77e+11. What is the difference between the Expenses (in $) in Germany in 2009 and the Expenses (in $) in Ireland in 2010?
Offer a very short reply. 3.07e+09. What is the difference between the Expenses (in $) in Hungary in 2009 and the Expenses (in $) in Ireland in 2010?
Keep it short and to the point. 9.76e+11. What is the difference between the Expenses (in $) of Armenia in 2009 and the Expenses (in $) of Germany in 2011?
Keep it short and to the point. 1.43e+11. What is the difference between the Expenses (in $) in Armenia in 2009 and the Expenses (in $) in Hungary in 2011?
Offer a terse response. -1.35e+12. What is the difference between the Expenses (in $) of Armenia in 2009 and the Expenses (in $) of Ireland in 2011?
Provide a succinct answer. 1.64e+11. What is the difference between the Expenses (in $) in Germany in 2009 and the Expenses (in $) in Hungary in 2011?
Your answer should be very brief. -1.48e+12. What is the difference between the Expenses (in $) in Germany in 2009 and the Expenses (in $) in Ireland in 2011?
Provide a short and direct response. 2.85e+1. What is the difference between the Expenses (in $) in Hungary in 2009 and the Expenses (in $) in Ireland in 2011?
Keep it short and to the point. 1.00e+12. What is the difference between the Expenses (in $) in Armenia in 2010 and the Expenses (in $) in Germany in 2011?
Your answer should be compact. 1.32e+11. What is the difference between the Expenses (in $) in Armenia in 2010 and the Expenses (in $) in Hungary in 2011?
Offer a terse response. -1.36e+12. What is the difference between the Expenses (in $) in Armenia in 2010 and the Expenses (in $) in Ireland in 2011?
Provide a succinct answer. 1.53e+11. What is the difference between the Expenses (in $) in Germany in 2010 and the Expenses (in $) in Hungary in 2011?
Your answer should be compact. -1.46e+12. What is the difference between the Expenses (in $) in Germany in 2010 and the Expenses (in $) in Ireland in 2011?
Ensure brevity in your answer.  5.37e+1. What is the difference between the Expenses (in $) of Hungary in 2010 and the Expenses (in $) of Ireland in 2011?
Ensure brevity in your answer.  1.01e+12. What is the average Expenses (in $) of Armenia per year?
Your answer should be very brief. 9.58e+1. What is the average Expenses (in $) of Germany per year?
Make the answer very short. 3.32e+1. What is the average Expenses (in $) in Hungary per year?
Offer a terse response. 1.05e+12. What is the average Expenses (in $) of Ireland per year?
Your answer should be very brief. 5.93e+09. In the year 2004, what is the difference between the Expenses (in $) of Armenia and Expenses (in $) of Germany?
Provide a short and direct response. -6.55e+09. In the year 2004, what is the difference between the Expenses (in $) of Armenia and Expenses (in $) of Hungary?
Make the answer very short. -8.18e+11. In the year 2004, what is the difference between the Expenses (in $) in Armenia and Expenses (in $) in Ireland?
Ensure brevity in your answer.  1.95e+1. In the year 2004, what is the difference between the Expenses (in $) of Germany and Expenses (in $) of Hungary?
Offer a terse response. -8.11e+11. In the year 2004, what is the difference between the Expenses (in $) in Germany and Expenses (in $) in Ireland?
Make the answer very short. 2.60e+1. In the year 2004, what is the difference between the Expenses (in $) of Hungary and Expenses (in $) of Ireland?
Your answer should be very brief. 8.37e+11. In the year 2005, what is the difference between the Expenses (in $) in Armenia and Expenses (in $) in Germany?
Your answer should be compact. -2.33e+1. In the year 2005, what is the difference between the Expenses (in $) in Armenia and Expenses (in $) in Hungary?
Your answer should be very brief. -8.32e+11. In the year 2005, what is the difference between the Expenses (in $) of Armenia and Expenses (in $) of Ireland?
Provide a short and direct response. 2.51e+09. In the year 2005, what is the difference between the Expenses (in $) of Germany and Expenses (in $) of Hungary?
Give a very brief answer. -8.09e+11. In the year 2005, what is the difference between the Expenses (in $) in Germany and Expenses (in $) in Ireland?
Offer a terse response. 2.58e+1. In the year 2005, what is the difference between the Expenses (in $) in Hungary and Expenses (in $) in Ireland?
Offer a very short reply. 8.35e+11. In the year 2006, what is the difference between the Expenses (in $) in Armenia and Expenses (in $) in Germany?
Your answer should be very brief. -4.60e+09. In the year 2006, what is the difference between the Expenses (in $) of Armenia and Expenses (in $) of Hungary?
Your answer should be compact. -9.91e+11. In the year 2006, what is the difference between the Expenses (in $) of Armenia and Expenses (in $) of Ireland?
Give a very brief answer. 2.07e+1. In the year 2006, what is the difference between the Expenses (in $) of Germany and Expenses (in $) of Hungary?
Offer a very short reply. -9.87e+11. In the year 2006, what is the difference between the Expenses (in $) of Germany and Expenses (in $) of Ireland?
Your answer should be compact. 2.53e+1. In the year 2006, what is the difference between the Expenses (in $) of Hungary and Expenses (in $) of Ireland?
Make the answer very short. 1.01e+12. In the year 2007, what is the difference between the Expenses (in $) in Armenia and Expenses (in $) in Germany?
Your response must be concise. 2.80e+09. In the year 2007, what is the difference between the Expenses (in $) of Armenia and Expenses (in $) of Hungary?
Keep it short and to the point. -1.11e+12. In the year 2007, what is the difference between the Expenses (in $) in Armenia and Expenses (in $) in Ireland?
Ensure brevity in your answer.  2.94e+1. In the year 2007, what is the difference between the Expenses (in $) in Germany and Expenses (in $) in Hungary?
Give a very brief answer. -1.12e+12. In the year 2007, what is the difference between the Expenses (in $) of Germany and Expenses (in $) of Ireland?
Offer a very short reply. 2.66e+1. In the year 2007, what is the difference between the Expenses (in $) in Hungary and Expenses (in $) in Ireland?
Ensure brevity in your answer.  1.14e+12. In the year 2008, what is the difference between the Expenses (in $) in Armenia and Expenses (in $) in Germany?
Your answer should be compact. 1.38e+11. In the year 2008, what is the difference between the Expenses (in $) of Armenia and Expenses (in $) of Hungary?
Give a very brief answer. -8.70e+11. In the year 2008, what is the difference between the Expenses (in $) of Armenia and Expenses (in $) of Ireland?
Make the answer very short. 1.68e+11. In the year 2008, what is the difference between the Expenses (in $) in Germany and Expenses (in $) in Hungary?
Make the answer very short. -1.01e+12. In the year 2008, what is the difference between the Expenses (in $) in Germany and Expenses (in $) in Ireland?
Keep it short and to the point. 2.99e+1. In the year 2008, what is the difference between the Expenses (in $) of Hungary and Expenses (in $) of Ireland?
Give a very brief answer. 1.04e+12. In the year 2009, what is the difference between the Expenses (in $) of Armenia and Expenses (in $) of Germany?
Make the answer very short. 1.35e+11. In the year 2009, what is the difference between the Expenses (in $) in Armenia and Expenses (in $) in Hungary?
Provide a short and direct response. -8.38e+11. In the year 2009, what is the difference between the Expenses (in $) in Armenia and Expenses (in $) in Ireland?
Your answer should be very brief. 1.71e+11. In the year 2009, what is the difference between the Expenses (in $) of Germany and Expenses (in $) of Hungary?
Offer a terse response. -9.73e+11. In the year 2009, what is the difference between the Expenses (in $) of Germany and Expenses (in $) of Ireland?
Ensure brevity in your answer.  3.58e+1. In the year 2009, what is the difference between the Expenses (in $) of Hungary and Expenses (in $) of Ireland?
Provide a short and direct response. 1.01e+12. In the year 2010, what is the difference between the Expenses (in $) of Armenia and Expenses (in $) of Germany?
Offer a terse response. 9.91e+1. In the year 2010, what is the difference between the Expenses (in $) of Armenia and Expenses (in $) of Hungary?
Ensure brevity in your answer.  -8.53e+11. In the year 2010, what is the difference between the Expenses (in $) in Armenia and Expenses (in $) in Ireland?
Your answer should be very brief. 1.27e+11. In the year 2010, what is the difference between the Expenses (in $) of Germany and Expenses (in $) of Hungary?
Give a very brief answer. -9.52e+11. In the year 2010, what is the difference between the Expenses (in $) in Germany and Expenses (in $) in Ireland?
Offer a terse response. 2.83e+1. In the year 2010, what is the difference between the Expenses (in $) in Hungary and Expenses (in $) in Ireland?
Your answer should be very brief. 9.80e+11. In the year 2011, what is the difference between the Expenses (in $) of Armenia and Expenses (in $) of Germany?
Your answer should be compact. 1.60e+11. In the year 2011, what is the difference between the Expenses (in $) in Armenia and Expenses (in $) in Hungary?
Make the answer very short. -1.33e+12. In the year 2011, what is the difference between the Expenses (in $) of Armenia and Expenses (in $) of Ireland?
Your response must be concise. 1.80e+11. In the year 2011, what is the difference between the Expenses (in $) in Germany and Expenses (in $) in Hungary?
Your response must be concise. -1.49e+12. In the year 2011, what is the difference between the Expenses (in $) of Germany and Expenses (in $) of Ireland?
Provide a succinct answer. 2.04e+1. In the year 2011, what is the difference between the Expenses (in $) of Hungary and Expenses (in $) of Ireland?
Make the answer very short. 1.51e+12. What is the ratio of the Expenses (in $) in Armenia in 2004 to that in 2005?
Your response must be concise. 6.07. What is the ratio of the Expenses (in $) of Hungary in 2004 to that in 2005?
Your answer should be compact. 1. What is the ratio of the Expenses (in $) of Ireland in 2004 to that in 2005?
Keep it short and to the point. 0.74. What is the ratio of the Expenses (in $) in Armenia in 2004 to that in 2006?
Offer a very short reply. 0.93. What is the ratio of the Expenses (in $) in Germany in 2004 to that in 2006?
Provide a short and direct response. 1.01. What is the ratio of the Expenses (in $) in Hungary in 2004 to that in 2006?
Your answer should be compact. 0.83. What is the ratio of the Expenses (in $) in Ireland in 2004 to that in 2006?
Keep it short and to the point. 0.65. What is the ratio of the Expenses (in $) in Armenia in 2004 to that in 2007?
Ensure brevity in your answer.  0.66. What is the ratio of the Expenses (in $) of Germany in 2004 to that in 2007?
Offer a very short reply. 0.96. What is the ratio of the Expenses (in $) of Hungary in 2004 to that in 2007?
Provide a succinct answer. 0.73. What is the ratio of the Expenses (in $) in Ireland in 2004 to that in 2007?
Offer a very short reply. 0.61. What is the ratio of the Expenses (in $) in Armenia in 2004 to that in 2008?
Ensure brevity in your answer.  0.12. What is the ratio of the Expenses (in $) of Germany in 2004 to that in 2008?
Give a very brief answer. 0.86. What is the ratio of the Expenses (in $) of Hungary in 2004 to that in 2008?
Provide a succinct answer. 0.81. What is the ratio of the Expenses (in $) of Ireland in 2004 to that in 2008?
Your response must be concise. 0.59. What is the ratio of the Expenses (in $) in Armenia in 2004 to that in 2009?
Give a very brief answer. 0.12. What is the ratio of the Expenses (in $) of Germany in 2004 to that in 2009?
Provide a succinct answer. 0.72. What is the ratio of the Expenses (in $) of Hungary in 2004 to that in 2009?
Provide a succinct answer. 0.83. What is the ratio of the Expenses (in $) in Ireland in 2004 to that in 2009?
Your response must be concise. 0.59. What is the ratio of the Expenses (in $) in Armenia in 2004 to that in 2010?
Give a very brief answer. 0.12. What is the ratio of the Expenses (in $) of Germany in 2004 to that in 2010?
Offer a terse response. 0.43. What is the ratio of the Expenses (in $) in Hungary in 2004 to that in 2010?
Make the answer very short. 0.83. What is the ratio of the Expenses (in $) of Ireland in 2004 to that in 2010?
Offer a very short reply. 0.02. What is the ratio of the Expenses (in $) in Armenia in 2004 to that in 2011?
Provide a succinct answer. 0.11. What is the ratio of the Expenses (in $) in Germany in 2004 to that in 2011?
Provide a short and direct response. 0.92. What is the ratio of the Expenses (in $) of Hungary in 2004 to that in 2011?
Give a very brief answer. 0.55. What is the ratio of the Expenses (in $) of Ireland in 2004 to that in 2011?
Provide a short and direct response. 0.07. What is the ratio of the Expenses (in $) in Armenia in 2005 to that in 2006?
Provide a short and direct response. 0.15. What is the ratio of the Expenses (in $) of Germany in 2005 to that in 2006?
Your answer should be very brief. 1.01. What is the ratio of the Expenses (in $) in Hungary in 2005 to that in 2006?
Your response must be concise. 0.82. What is the ratio of the Expenses (in $) in Ireland in 2005 to that in 2006?
Keep it short and to the point. 0.87. What is the ratio of the Expenses (in $) in Armenia in 2005 to that in 2007?
Your answer should be compact. 0.11. What is the ratio of the Expenses (in $) of Germany in 2005 to that in 2007?
Your answer should be compact. 0.96. What is the ratio of the Expenses (in $) of Hungary in 2005 to that in 2007?
Provide a succinct answer. 0.73. What is the ratio of the Expenses (in $) in Ireland in 2005 to that in 2007?
Provide a succinct answer. 0.82. What is the ratio of the Expenses (in $) of Armenia in 2005 to that in 2008?
Your response must be concise. 0.02. What is the ratio of the Expenses (in $) of Germany in 2005 to that in 2008?
Provide a succinct answer. 0.86. What is the ratio of the Expenses (in $) of Hungary in 2005 to that in 2008?
Keep it short and to the point. 0.8. What is the ratio of the Expenses (in $) of Ireland in 2005 to that in 2008?
Offer a terse response. 0.79. What is the ratio of the Expenses (in $) in Armenia in 2005 to that in 2009?
Make the answer very short. 0.02. What is the ratio of the Expenses (in $) of Germany in 2005 to that in 2009?
Your response must be concise. 0.72. What is the ratio of the Expenses (in $) of Hungary in 2005 to that in 2009?
Provide a short and direct response. 0.83. What is the ratio of the Expenses (in $) in Ireland in 2005 to that in 2009?
Make the answer very short. 0.8. What is the ratio of the Expenses (in $) in Armenia in 2005 to that in 2010?
Your response must be concise. 0.02. What is the ratio of the Expenses (in $) in Germany in 2005 to that in 2010?
Your answer should be compact. 0.43. What is the ratio of the Expenses (in $) of Hungary in 2005 to that in 2010?
Give a very brief answer. 0.82. What is the ratio of the Expenses (in $) of Ireland in 2005 to that in 2010?
Provide a short and direct response. 0.02. What is the ratio of the Expenses (in $) of Armenia in 2005 to that in 2011?
Ensure brevity in your answer.  0.02. What is the ratio of the Expenses (in $) in Germany in 2005 to that in 2011?
Your answer should be compact. 0.92. What is the ratio of the Expenses (in $) of Hungary in 2005 to that in 2011?
Provide a short and direct response. 0.55. What is the ratio of the Expenses (in $) of Ireland in 2005 to that in 2011?
Provide a short and direct response. 0.1. What is the ratio of the Expenses (in $) in Armenia in 2006 to that in 2007?
Provide a short and direct response. 0.71. What is the ratio of the Expenses (in $) of Hungary in 2006 to that in 2007?
Keep it short and to the point. 0.88. What is the ratio of the Expenses (in $) in Ireland in 2006 to that in 2007?
Make the answer very short. 0.94. What is the ratio of the Expenses (in $) in Armenia in 2006 to that in 2008?
Offer a terse response. 0.13. What is the ratio of the Expenses (in $) in Germany in 2006 to that in 2008?
Your answer should be very brief. 0.85. What is the ratio of the Expenses (in $) of Hungary in 2006 to that in 2008?
Offer a terse response. 0.98. What is the ratio of the Expenses (in $) of Ireland in 2006 to that in 2008?
Your answer should be compact. 0.91. What is the ratio of the Expenses (in $) in Armenia in 2006 to that in 2009?
Make the answer very short. 0.13. What is the ratio of the Expenses (in $) in Germany in 2006 to that in 2009?
Your response must be concise. 0.71. What is the ratio of the Expenses (in $) in Ireland in 2006 to that in 2009?
Your answer should be compact. 0.92. What is the ratio of the Expenses (in $) in Armenia in 2006 to that in 2010?
Give a very brief answer. 0.13. What is the ratio of the Expenses (in $) in Germany in 2006 to that in 2010?
Your answer should be very brief. 0.42. What is the ratio of the Expenses (in $) of Hungary in 2006 to that in 2010?
Give a very brief answer. 1. What is the ratio of the Expenses (in $) in Ireland in 2006 to that in 2010?
Your answer should be compact. 0.03. What is the ratio of the Expenses (in $) in Armenia in 2006 to that in 2011?
Your answer should be very brief. 0.11. What is the ratio of the Expenses (in $) of Germany in 2006 to that in 2011?
Keep it short and to the point. 0.91. What is the ratio of the Expenses (in $) of Hungary in 2006 to that in 2011?
Offer a terse response. 0.67. What is the ratio of the Expenses (in $) of Ireland in 2006 to that in 2011?
Your answer should be compact. 0.11. What is the ratio of the Expenses (in $) in Armenia in 2007 to that in 2008?
Make the answer very short. 0.18. What is the ratio of the Expenses (in $) of Germany in 2007 to that in 2008?
Your answer should be compact. 0.89. What is the ratio of the Expenses (in $) of Hungary in 2007 to that in 2008?
Keep it short and to the point. 1.1. What is the ratio of the Expenses (in $) in Ireland in 2007 to that in 2008?
Your response must be concise. 0.97. What is the ratio of the Expenses (in $) of Armenia in 2007 to that in 2009?
Make the answer very short. 0.18. What is the ratio of the Expenses (in $) in Germany in 2007 to that in 2009?
Make the answer very short. 0.75. What is the ratio of the Expenses (in $) of Hungary in 2007 to that in 2009?
Keep it short and to the point. 1.13. What is the ratio of the Expenses (in $) of Ireland in 2007 to that in 2009?
Provide a succinct answer. 0.98. What is the ratio of the Expenses (in $) of Armenia in 2007 to that in 2010?
Ensure brevity in your answer.  0.19. What is the ratio of the Expenses (in $) in Germany in 2007 to that in 2010?
Make the answer very short. 0.44. What is the ratio of the Expenses (in $) in Hungary in 2007 to that in 2010?
Keep it short and to the point. 1.13. What is the ratio of the Expenses (in $) in Ireland in 2007 to that in 2010?
Provide a succinct answer. 0.03. What is the ratio of the Expenses (in $) in Armenia in 2007 to that in 2011?
Give a very brief answer. 0.16. What is the ratio of the Expenses (in $) of Germany in 2007 to that in 2011?
Your response must be concise. 0.96. What is the ratio of the Expenses (in $) of Hungary in 2007 to that in 2011?
Your answer should be very brief. 0.75. What is the ratio of the Expenses (in $) in Ireland in 2007 to that in 2011?
Offer a terse response. 0.12. What is the ratio of the Expenses (in $) in Armenia in 2008 to that in 2009?
Provide a short and direct response. 0.98. What is the ratio of the Expenses (in $) of Germany in 2008 to that in 2009?
Your answer should be very brief. 0.84. What is the ratio of the Expenses (in $) of Hungary in 2008 to that in 2009?
Your answer should be very brief. 1.03. What is the ratio of the Expenses (in $) in Ireland in 2008 to that in 2009?
Your answer should be compact. 1.01. What is the ratio of the Expenses (in $) in Armenia in 2008 to that in 2010?
Provide a succinct answer. 1.05. What is the ratio of the Expenses (in $) of Germany in 2008 to that in 2010?
Ensure brevity in your answer.  0.5. What is the ratio of the Expenses (in $) in Hungary in 2008 to that in 2010?
Ensure brevity in your answer.  1.02. What is the ratio of the Expenses (in $) in Ireland in 2008 to that in 2010?
Ensure brevity in your answer.  0.03. What is the ratio of the Expenses (in $) of Armenia in 2008 to that in 2011?
Ensure brevity in your answer.  0.9. What is the ratio of the Expenses (in $) of Germany in 2008 to that in 2011?
Offer a terse response. 1.07. What is the ratio of the Expenses (in $) of Hungary in 2008 to that in 2011?
Give a very brief answer. 0.68. What is the ratio of the Expenses (in $) in Ireland in 2008 to that in 2011?
Provide a short and direct response. 0.12. What is the ratio of the Expenses (in $) of Armenia in 2009 to that in 2010?
Provide a short and direct response. 1.07. What is the ratio of the Expenses (in $) of Germany in 2009 to that in 2010?
Ensure brevity in your answer.  0.59. What is the ratio of the Expenses (in $) of Ireland in 2009 to that in 2010?
Keep it short and to the point. 0.03. What is the ratio of the Expenses (in $) in Armenia in 2009 to that in 2011?
Make the answer very short. 0.91. What is the ratio of the Expenses (in $) of Germany in 2009 to that in 2011?
Provide a succinct answer. 1.28. What is the ratio of the Expenses (in $) in Hungary in 2009 to that in 2011?
Your answer should be very brief. 0.67. What is the ratio of the Expenses (in $) in Ireland in 2009 to that in 2011?
Offer a terse response. 0.12. What is the ratio of the Expenses (in $) of Armenia in 2010 to that in 2011?
Ensure brevity in your answer.  0.86. What is the ratio of the Expenses (in $) in Germany in 2010 to that in 2011?
Ensure brevity in your answer.  2.16. What is the ratio of the Expenses (in $) in Hungary in 2010 to that in 2011?
Make the answer very short. 0.67. What is the ratio of the Expenses (in $) in Ireland in 2010 to that in 2011?
Keep it short and to the point. 4.03. What is the difference between the highest and the second highest Expenses (in $) in Armenia?
Keep it short and to the point. 1.63e+1. What is the difference between the highest and the second highest Expenses (in $) of Germany?
Keep it short and to the point. 2.52e+1. What is the difference between the highest and the second highest Expenses (in $) of Hungary?
Make the answer very short. 3.72e+11. What is the difference between the highest and the second highest Expenses (in $) in Ireland?
Your answer should be compact. 2.54e+1. What is the difference between the highest and the lowest Expenses (in $) of Armenia?
Make the answer very short. 1.85e+11. What is the difference between the highest and the lowest Expenses (in $) of Germany?
Provide a succinct answer. 3.59e+1. What is the difference between the highest and the lowest Expenses (in $) in Hungary?
Your answer should be very brief. 6.82e+11. What is the difference between the highest and the lowest Expenses (in $) of Ireland?
Offer a very short reply. 3.32e+1. 